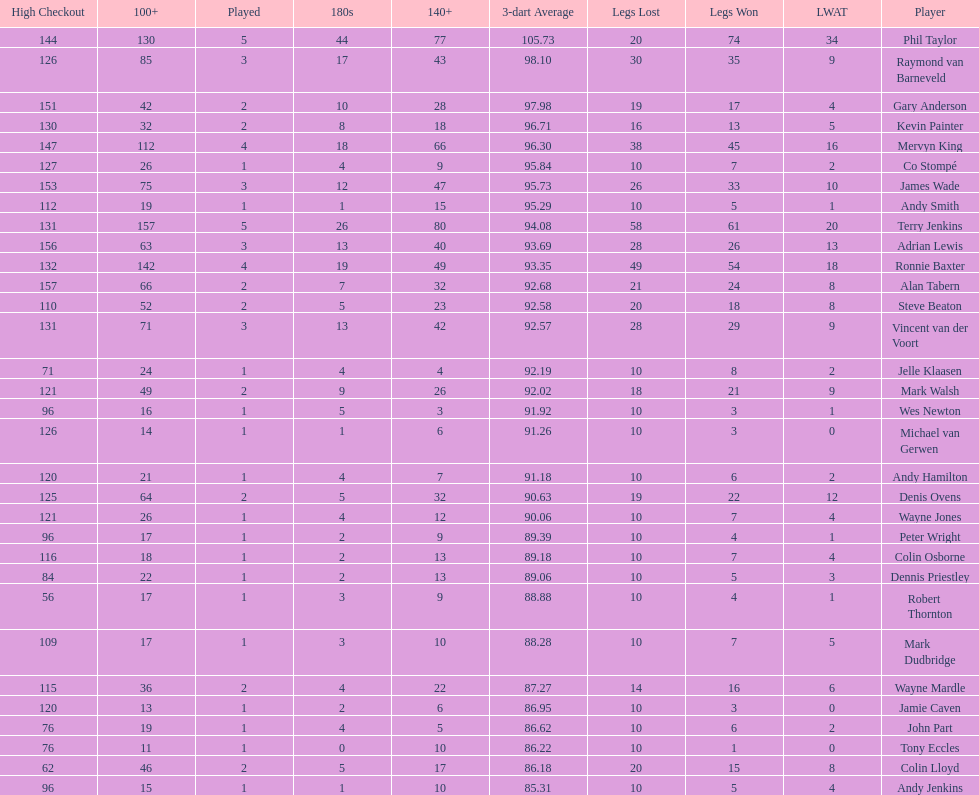List each of the players with a high checkout of 131. Terry Jenkins, Vincent van der Voort. 